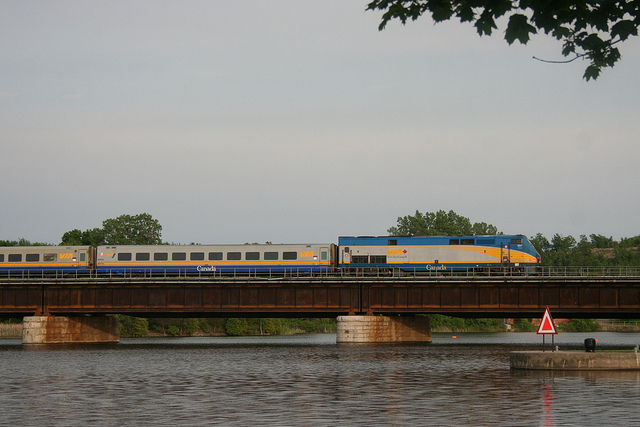<image>What is advertised here? I'm not sure. It can be 'Canada', 'train' or nothing being advertised here. What is advertised here? I don't know what is advertised here. It can be either nothing or something related to Canada or trains. 